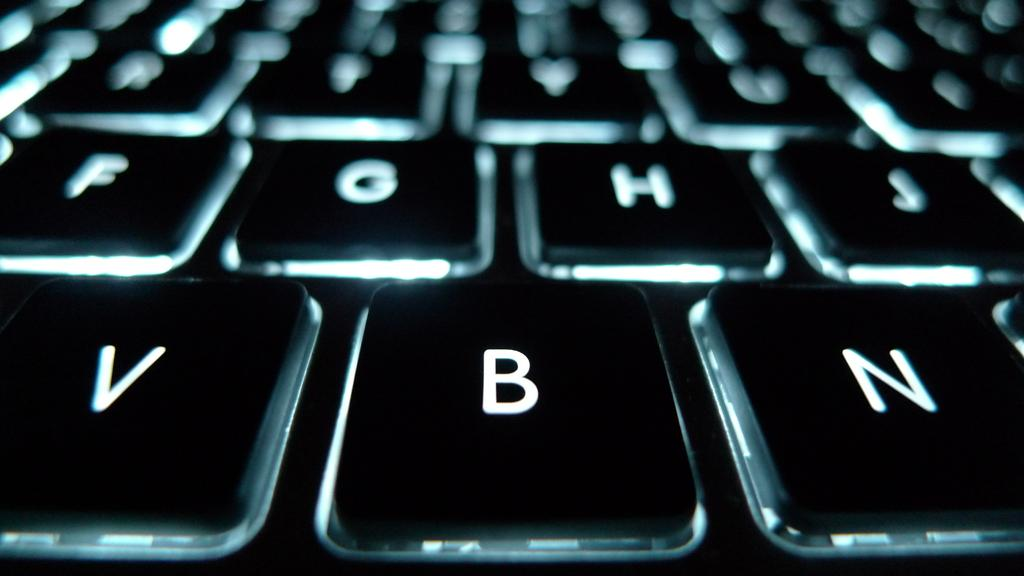<image>
Create a compact narrative representing the image presented. Keyboard with alphabet letters like V, B, N, H, and J. 